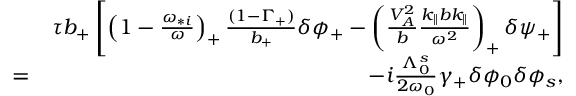<formula> <loc_0><loc_0><loc_500><loc_500>\begin{array} { r l r } & { \tau b _ { + } \left [ \left ( 1 - \frac { \omega _ { * i } } { \omega } \right ) _ { + } \frac { ( 1 - \Gamma _ { + } ) } { b _ { + } } \delta \phi _ { + } - \left ( \frac { V _ { A } ^ { 2 } } { b } \frac { k _ { \| } b k _ { \| } } { \omega ^ { 2 } } \right ) _ { + } \delta \psi _ { + } \right ] } \\ & { = } & { - i \frac { \Lambda _ { 0 } ^ { s } } { 2 \omega _ { 0 } } \gamma _ { + } \delta \phi _ { 0 } \delta \phi _ { s } , } \end{array}</formula> 